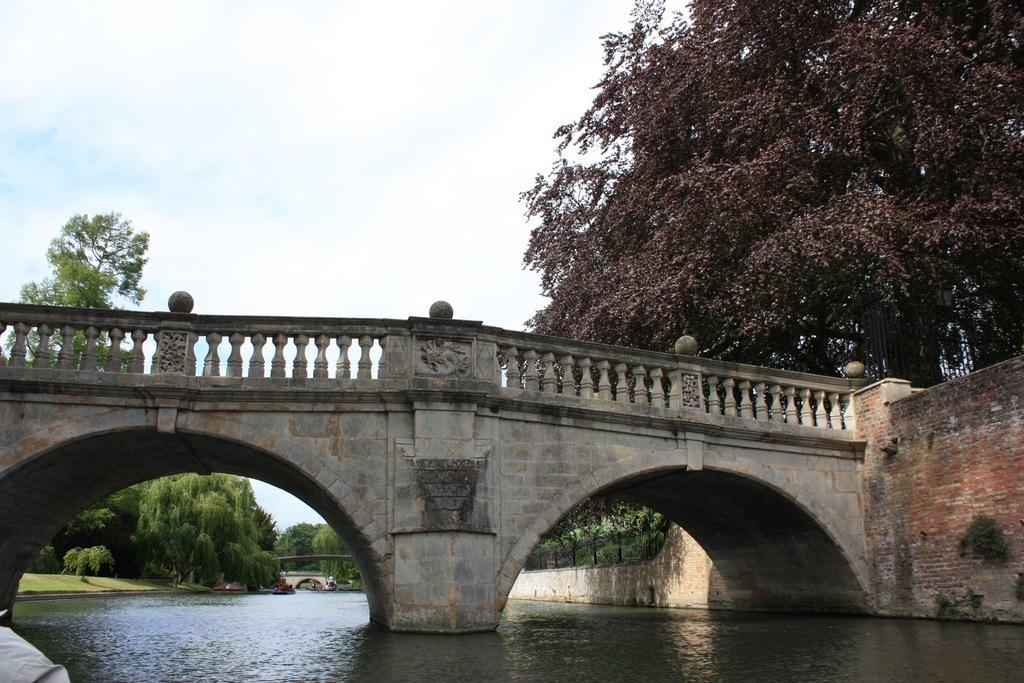What type of structure is present in the image? There is a bridgewater in the image. What material is used to construct the wall in the image? The wall in the image is made of bricks. What type of vegetation can be seen in the image? There are trees in the image. What is visible in the background of the image? The sky is visible in the image. How many pies are stacked on top of the brick wall in the image? There are no pies present in the image; it features a bridgewater, trees, and a brick wall. What type of vegetable is growing on the trees in the image? There are no vegetables growing on the trees in the image; the trees are not specified as fruit-bearing trees. 